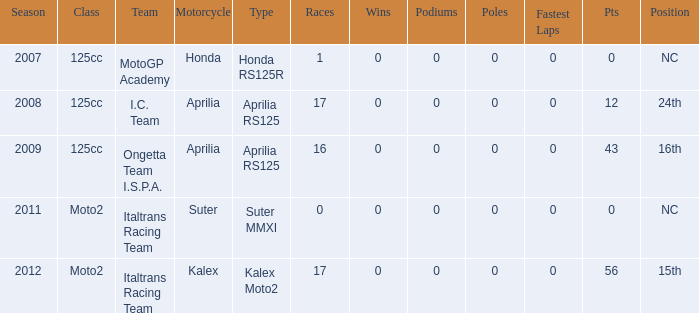What's the name of the team who had a Honda motorcycle? MotoGP Academy. 